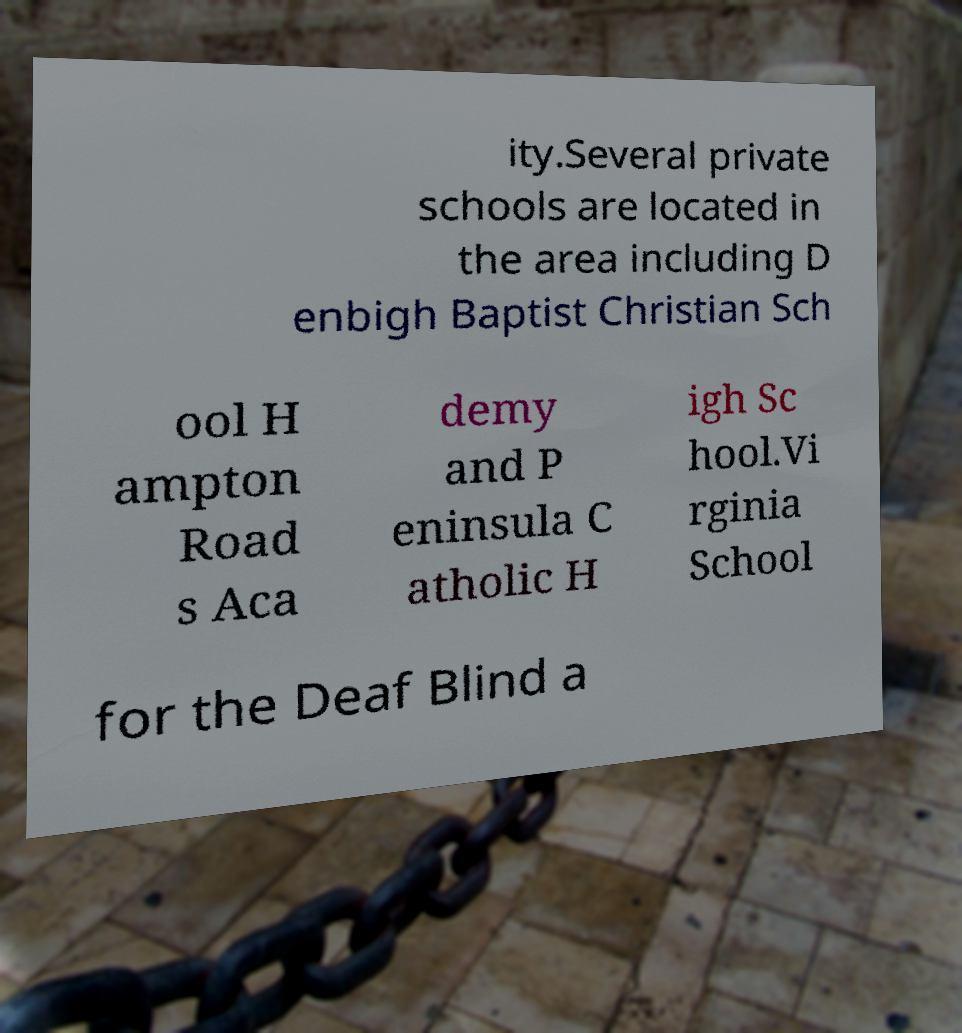For documentation purposes, I need the text within this image transcribed. Could you provide that? ity.Several private schools are located in the area including D enbigh Baptist Christian Sch ool H ampton Road s Aca demy and P eninsula C atholic H igh Sc hool.Vi rginia School for the Deaf Blind a 